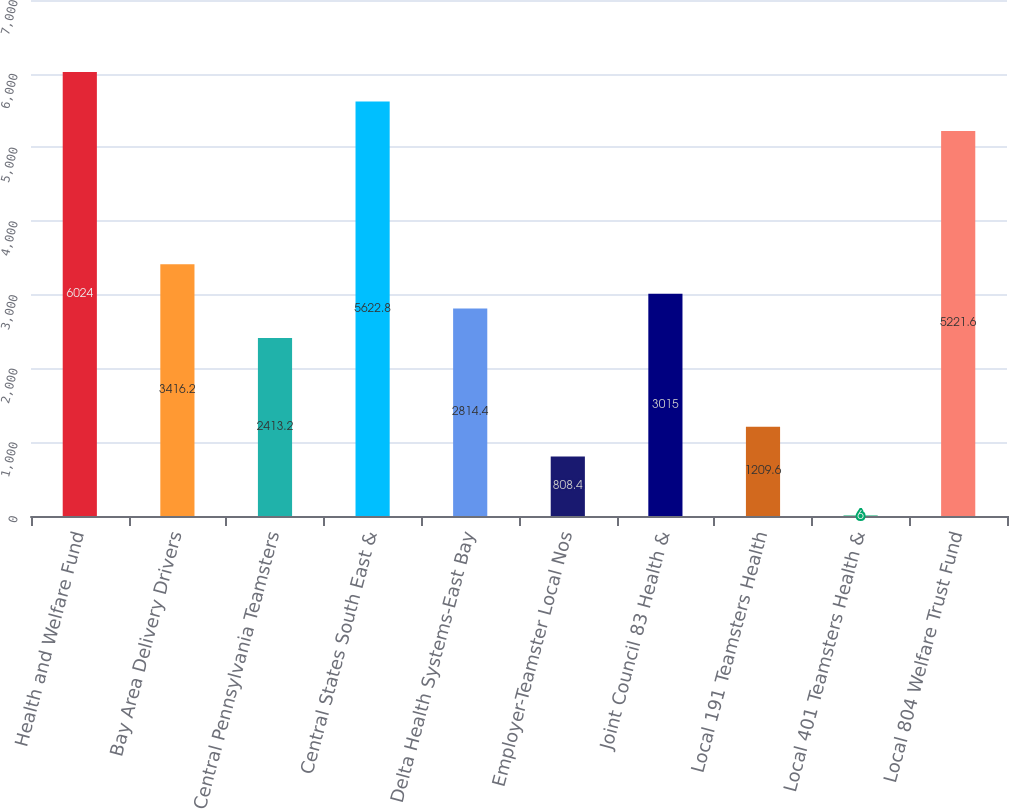Convert chart. <chart><loc_0><loc_0><loc_500><loc_500><bar_chart><fcel>Health and Welfare Fund<fcel>Bay Area Delivery Drivers<fcel>Central Pennsylvania Teamsters<fcel>Central States South East &<fcel>Delta Health Systems-East Bay<fcel>Employer-Teamster Local Nos<fcel>Joint Council 83 Health &<fcel>Local 191 Teamsters Health<fcel>Local 401 Teamsters Health &<fcel>Local 804 Welfare Trust Fund<nl><fcel>6024<fcel>3416.2<fcel>2413.2<fcel>5622.8<fcel>2814.4<fcel>808.4<fcel>3015<fcel>1209.6<fcel>6<fcel>5221.6<nl></chart> 